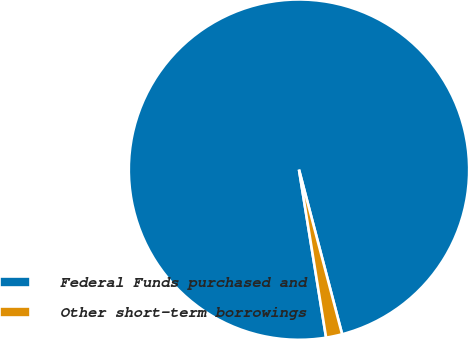<chart> <loc_0><loc_0><loc_500><loc_500><pie_chart><fcel>Federal Funds purchased and<fcel>Other short-term borrowings<nl><fcel>98.47%<fcel>1.53%<nl></chart> 